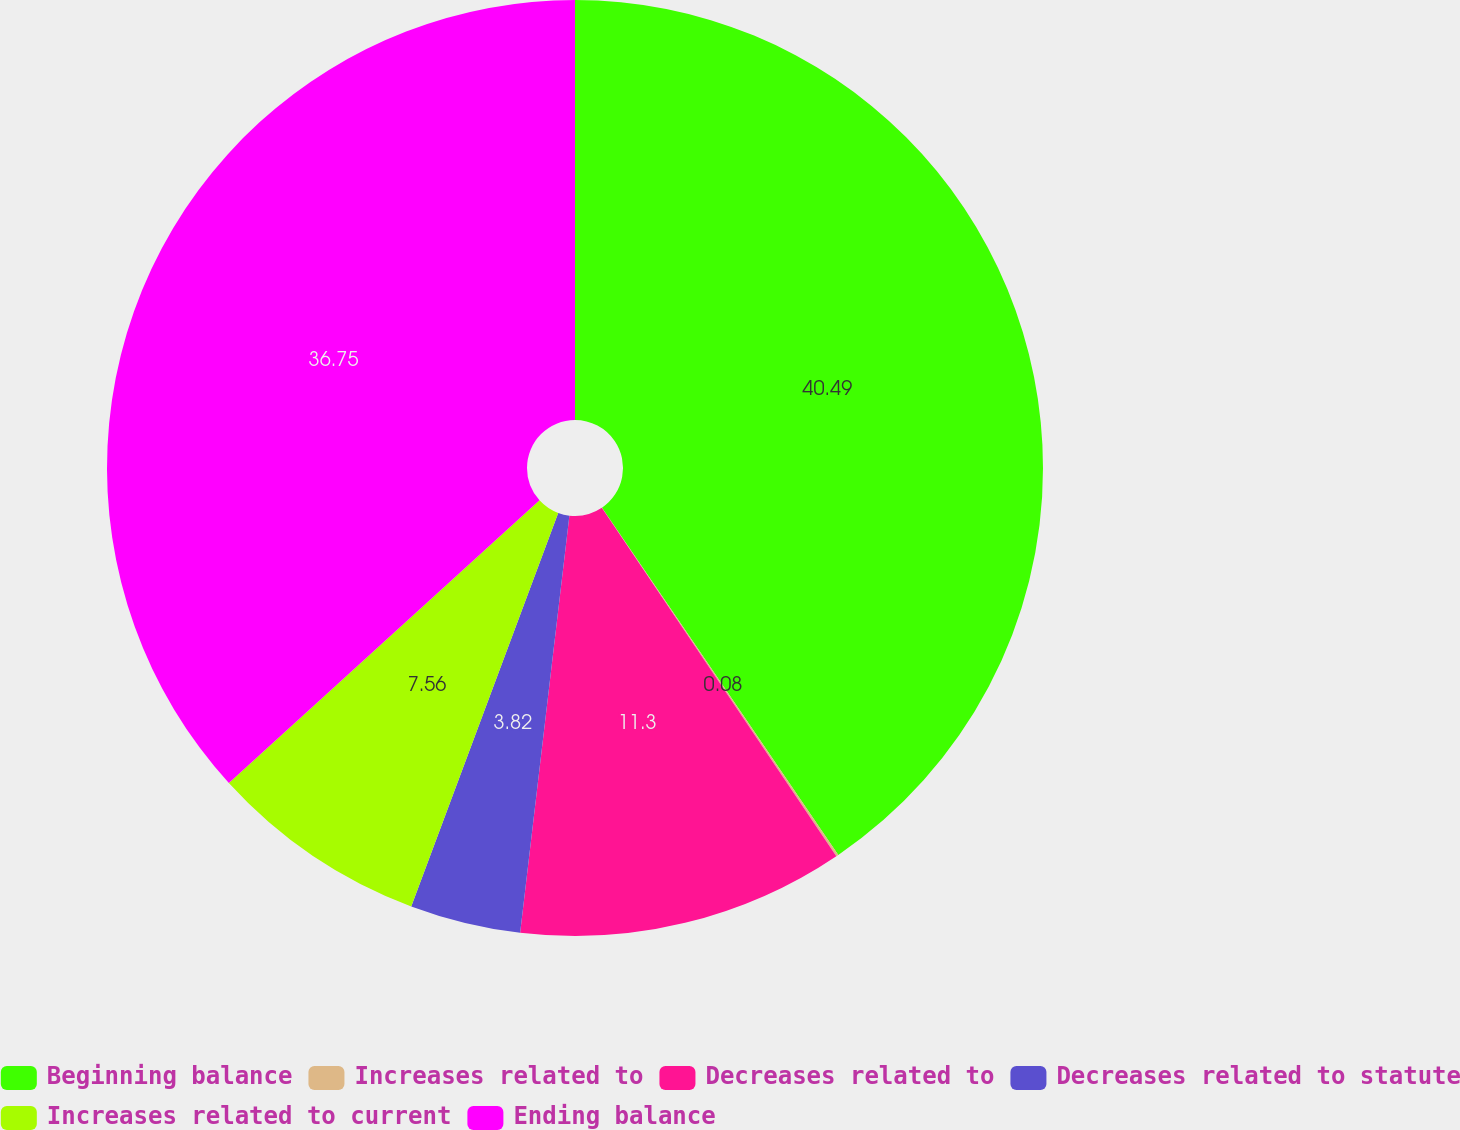Convert chart to OTSL. <chart><loc_0><loc_0><loc_500><loc_500><pie_chart><fcel>Beginning balance<fcel>Increases related to<fcel>Decreases related to<fcel>Decreases related to statute<fcel>Increases related to current<fcel>Ending balance<nl><fcel>40.49%<fcel>0.08%<fcel>11.3%<fcel>3.82%<fcel>7.56%<fcel>36.75%<nl></chart> 